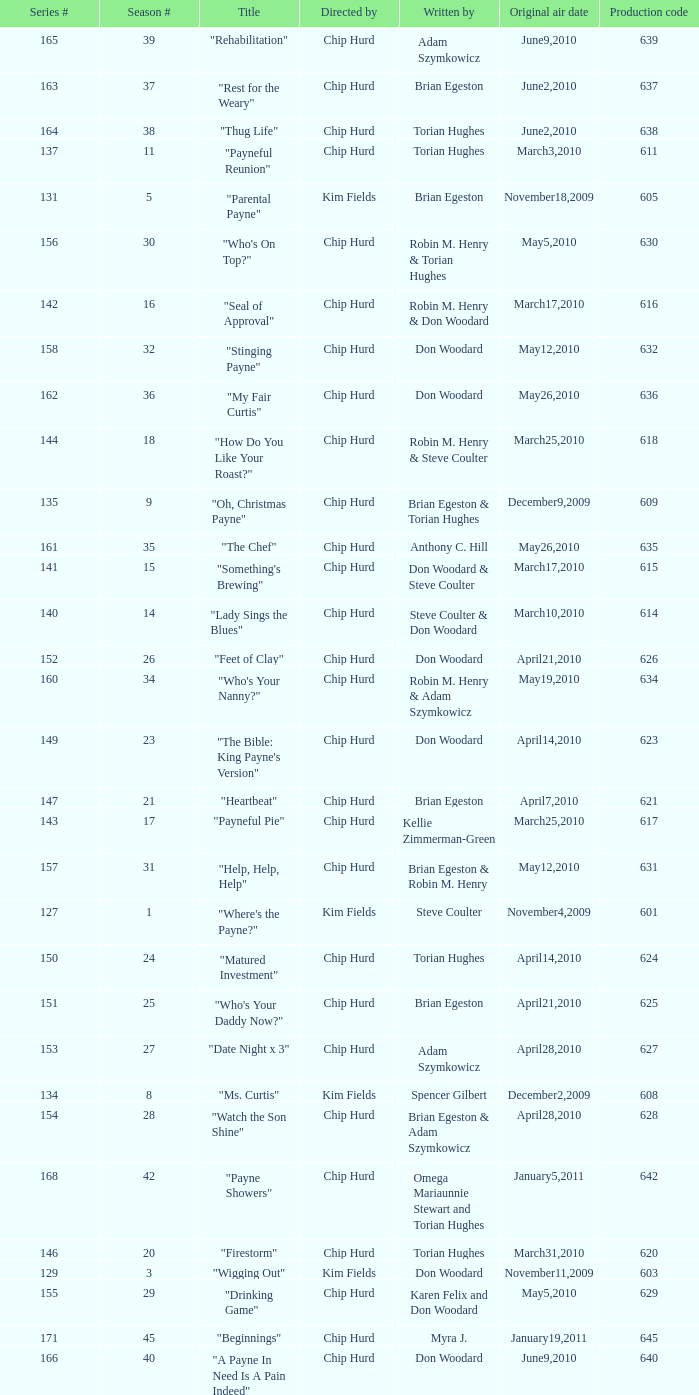What is the original air date of the episode written by Karen Felix and Don Woodard? May5,2010. 